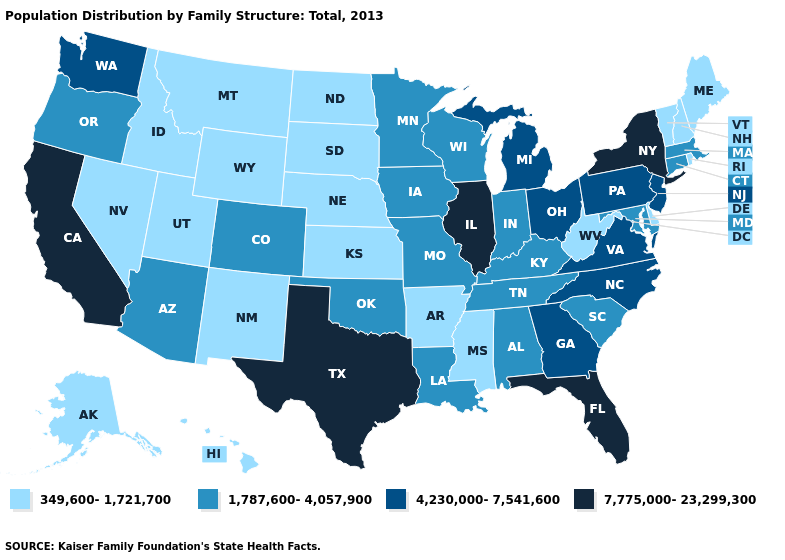How many symbols are there in the legend?
Write a very short answer. 4. Which states have the lowest value in the South?
Give a very brief answer. Arkansas, Delaware, Mississippi, West Virginia. Name the states that have a value in the range 1,787,600-4,057,900?
Write a very short answer. Alabama, Arizona, Colorado, Connecticut, Indiana, Iowa, Kentucky, Louisiana, Maryland, Massachusetts, Minnesota, Missouri, Oklahoma, Oregon, South Carolina, Tennessee, Wisconsin. Name the states that have a value in the range 7,775,000-23,299,300?
Keep it brief. California, Florida, Illinois, New York, Texas. Does the first symbol in the legend represent the smallest category?
Keep it brief. Yes. Does the map have missing data?
Short answer required. No. What is the lowest value in the USA?
Answer briefly. 349,600-1,721,700. Name the states that have a value in the range 1,787,600-4,057,900?
Give a very brief answer. Alabama, Arizona, Colorado, Connecticut, Indiana, Iowa, Kentucky, Louisiana, Maryland, Massachusetts, Minnesota, Missouri, Oklahoma, Oregon, South Carolina, Tennessee, Wisconsin. Does Vermont have a lower value than New Jersey?
Quick response, please. Yes. Does New York have the highest value in the Northeast?
Concise answer only. Yes. Which states have the lowest value in the USA?
Answer briefly. Alaska, Arkansas, Delaware, Hawaii, Idaho, Kansas, Maine, Mississippi, Montana, Nebraska, Nevada, New Hampshire, New Mexico, North Dakota, Rhode Island, South Dakota, Utah, Vermont, West Virginia, Wyoming. What is the highest value in the Northeast ?
Keep it brief. 7,775,000-23,299,300. Which states have the lowest value in the West?
Keep it brief. Alaska, Hawaii, Idaho, Montana, Nevada, New Mexico, Utah, Wyoming. What is the lowest value in states that border South Dakota?
Short answer required. 349,600-1,721,700. 